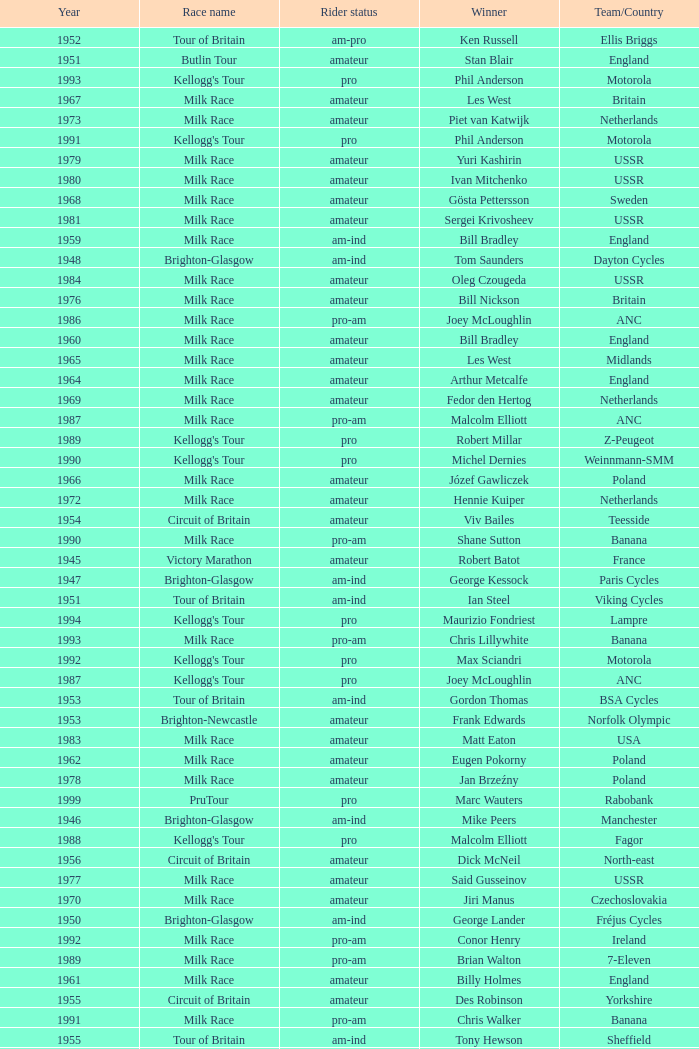Who was the winner in 1973 with an amateur rider status? Piet van Katwijk. 